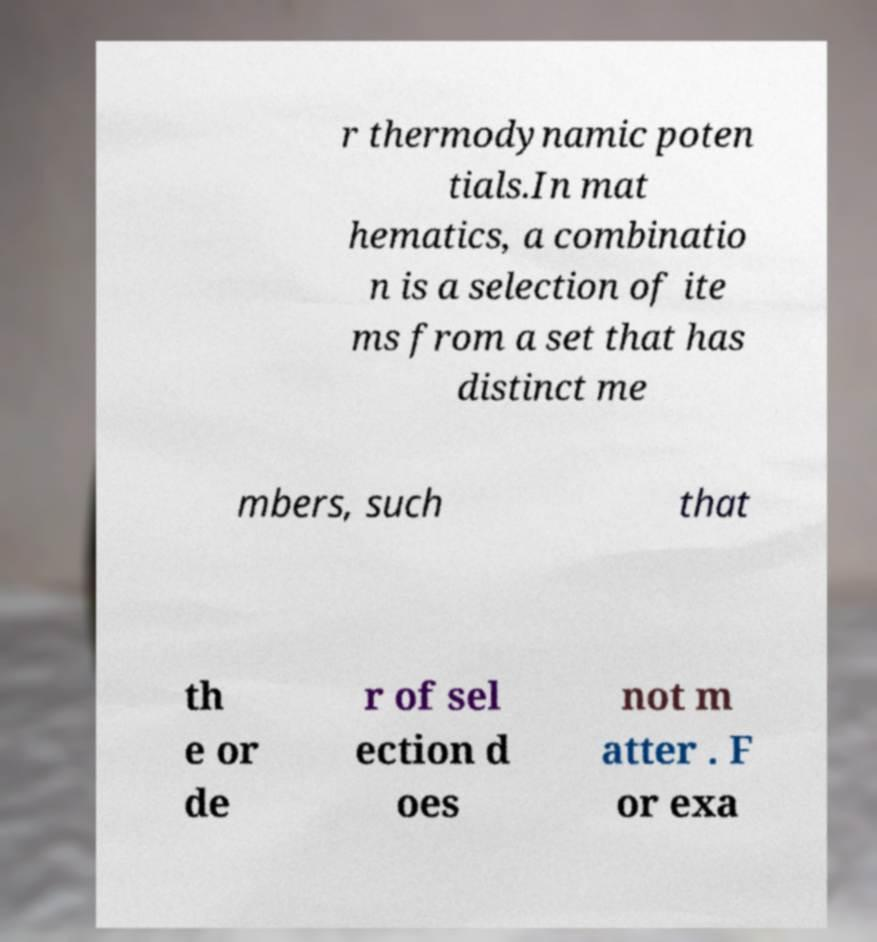For documentation purposes, I need the text within this image transcribed. Could you provide that? r thermodynamic poten tials.In mat hematics, a combinatio n is a selection of ite ms from a set that has distinct me mbers, such that th e or de r of sel ection d oes not m atter . F or exa 